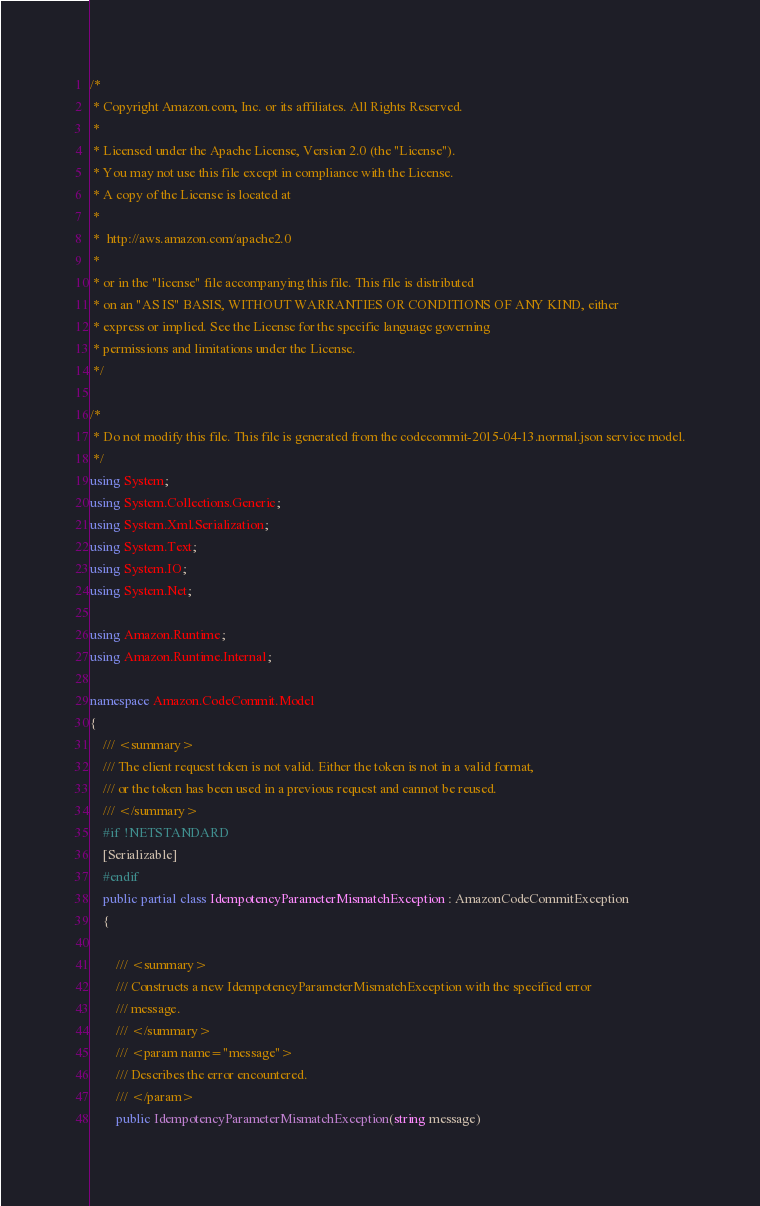<code> <loc_0><loc_0><loc_500><loc_500><_C#_>/*
 * Copyright Amazon.com, Inc. or its affiliates. All Rights Reserved.
 * 
 * Licensed under the Apache License, Version 2.0 (the "License").
 * You may not use this file except in compliance with the License.
 * A copy of the License is located at
 * 
 *  http://aws.amazon.com/apache2.0
 * 
 * or in the "license" file accompanying this file. This file is distributed
 * on an "AS IS" BASIS, WITHOUT WARRANTIES OR CONDITIONS OF ANY KIND, either
 * express or implied. See the License for the specific language governing
 * permissions and limitations under the License.
 */

/*
 * Do not modify this file. This file is generated from the codecommit-2015-04-13.normal.json service model.
 */
using System;
using System.Collections.Generic;
using System.Xml.Serialization;
using System.Text;
using System.IO;
using System.Net;

using Amazon.Runtime;
using Amazon.Runtime.Internal;

namespace Amazon.CodeCommit.Model
{
    /// <summary>
    /// The client request token is not valid. Either the token is not in a valid format,
    /// or the token has been used in a previous request and cannot be reused.
    /// </summary>
    #if !NETSTANDARD
    [Serializable]
    #endif
    public partial class IdempotencyParameterMismatchException : AmazonCodeCommitException
    {

        /// <summary>
        /// Constructs a new IdempotencyParameterMismatchException with the specified error
        /// message.
        /// </summary>
        /// <param name="message">
        /// Describes the error encountered.
        /// </param>
        public IdempotencyParameterMismatchException(string message) </code> 